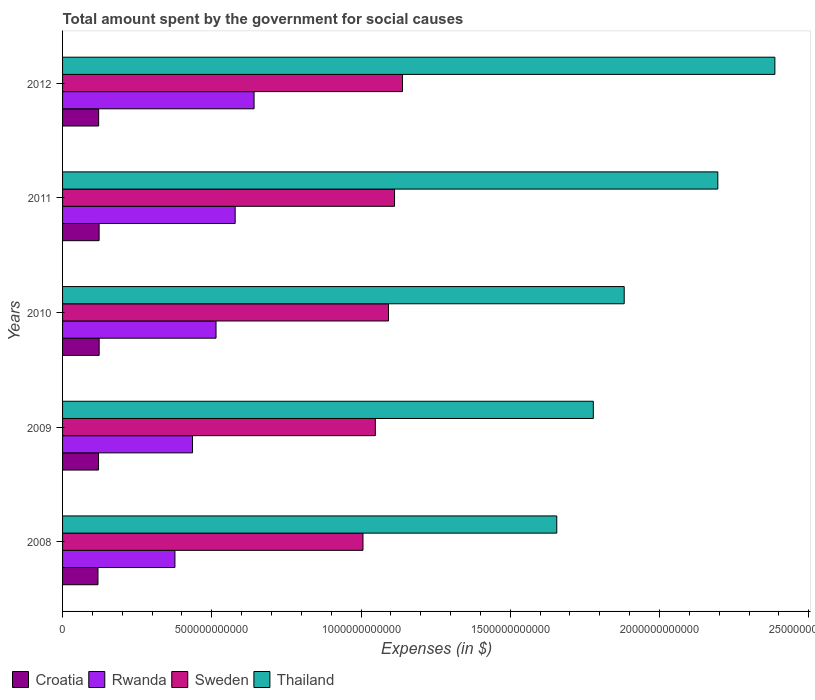Are the number of bars per tick equal to the number of legend labels?
Provide a succinct answer. Yes. How many bars are there on the 2nd tick from the top?
Your answer should be very brief. 4. In how many cases, is the number of bars for a given year not equal to the number of legend labels?
Offer a very short reply. 0. What is the amount spent for social causes by the government in Thailand in 2011?
Your response must be concise. 2.20e+12. Across all years, what is the maximum amount spent for social causes by the government in Thailand?
Keep it short and to the point. 2.39e+12. Across all years, what is the minimum amount spent for social causes by the government in Thailand?
Provide a short and direct response. 1.66e+12. What is the total amount spent for social causes by the government in Rwanda in the graph?
Offer a terse response. 2.55e+12. What is the difference between the amount spent for social causes by the government in Thailand in 2008 and that in 2010?
Provide a short and direct response. -2.26e+11. What is the difference between the amount spent for social causes by the government in Rwanda in 2010 and the amount spent for social causes by the government in Sweden in 2011?
Ensure brevity in your answer.  -5.98e+11. What is the average amount spent for social causes by the government in Rwanda per year?
Your answer should be compact. 5.09e+11. In the year 2012, what is the difference between the amount spent for social causes by the government in Thailand and amount spent for social causes by the government in Sweden?
Your response must be concise. 1.25e+12. What is the ratio of the amount spent for social causes by the government in Croatia in 2009 to that in 2011?
Offer a very short reply. 0.98. What is the difference between the highest and the second highest amount spent for social causes by the government in Thailand?
Make the answer very short. 1.91e+11. What is the difference between the highest and the lowest amount spent for social causes by the government in Sweden?
Offer a terse response. 1.32e+11. In how many years, is the amount spent for social causes by the government in Rwanda greater than the average amount spent for social causes by the government in Rwanda taken over all years?
Offer a very short reply. 3. Is the sum of the amount spent for social causes by the government in Rwanda in 2010 and 2012 greater than the maximum amount spent for social causes by the government in Sweden across all years?
Make the answer very short. Yes. Is it the case that in every year, the sum of the amount spent for social causes by the government in Rwanda and amount spent for social causes by the government in Croatia is greater than the sum of amount spent for social causes by the government in Thailand and amount spent for social causes by the government in Sweden?
Provide a succinct answer. No. What does the 4th bar from the top in 2011 represents?
Your answer should be very brief. Croatia. What does the 3rd bar from the bottom in 2008 represents?
Offer a terse response. Sweden. Is it the case that in every year, the sum of the amount spent for social causes by the government in Croatia and amount spent for social causes by the government in Thailand is greater than the amount spent for social causes by the government in Sweden?
Your answer should be compact. Yes. How many bars are there?
Your answer should be compact. 20. Are all the bars in the graph horizontal?
Make the answer very short. Yes. How many years are there in the graph?
Your answer should be very brief. 5. What is the difference between two consecutive major ticks on the X-axis?
Your answer should be very brief. 5.00e+11. Does the graph contain grids?
Offer a terse response. No. How many legend labels are there?
Provide a short and direct response. 4. What is the title of the graph?
Your answer should be very brief. Total amount spent by the government for social causes. What is the label or title of the X-axis?
Offer a terse response. Expenses (in $). What is the label or title of the Y-axis?
Your answer should be compact. Years. What is the Expenses (in $) in Croatia in 2008?
Provide a short and direct response. 1.19e+11. What is the Expenses (in $) in Rwanda in 2008?
Keep it short and to the point. 3.77e+11. What is the Expenses (in $) in Sweden in 2008?
Your response must be concise. 1.01e+12. What is the Expenses (in $) in Thailand in 2008?
Keep it short and to the point. 1.66e+12. What is the Expenses (in $) of Croatia in 2009?
Provide a short and direct response. 1.21e+11. What is the Expenses (in $) in Rwanda in 2009?
Offer a very short reply. 4.35e+11. What is the Expenses (in $) of Sweden in 2009?
Make the answer very short. 1.05e+12. What is the Expenses (in $) in Thailand in 2009?
Give a very brief answer. 1.78e+12. What is the Expenses (in $) in Croatia in 2010?
Keep it short and to the point. 1.23e+11. What is the Expenses (in $) in Rwanda in 2010?
Your answer should be compact. 5.14e+11. What is the Expenses (in $) in Sweden in 2010?
Provide a short and direct response. 1.09e+12. What is the Expenses (in $) of Thailand in 2010?
Ensure brevity in your answer.  1.88e+12. What is the Expenses (in $) of Croatia in 2011?
Your answer should be compact. 1.22e+11. What is the Expenses (in $) of Rwanda in 2011?
Your answer should be very brief. 5.78e+11. What is the Expenses (in $) of Sweden in 2011?
Your response must be concise. 1.11e+12. What is the Expenses (in $) of Thailand in 2011?
Make the answer very short. 2.20e+12. What is the Expenses (in $) of Croatia in 2012?
Provide a short and direct response. 1.21e+11. What is the Expenses (in $) of Rwanda in 2012?
Ensure brevity in your answer.  6.42e+11. What is the Expenses (in $) of Sweden in 2012?
Provide a succinct answer. 1.14e+12. What is the Expenses (in $) in Thailand in 2012?
Provide a short and direct response. 2.39e+12. Across all years, what is the maximum Expenses (in $) in Croatia?
Offer a terse response. 1.23e+11. Across all years, what is the maximum Expenses (in $) of Rwanda?
Provide a succinct answer. 6.42e+11. Across all years, what is the maximum Expenses (in $) in Sweden?
Give a very brief answer. 1.14e+12. Across all years, what is the maximum Expenses (in $) of Thailand?
Offer a very short reply. 2.39e+12. Across all years, what is the minimum Expenses (in $) of Croatia?
Your answer should be compact. 1.19e+11. Across all years, what is the minimum Expenses (in $) in Rwanda?
Provide a short and direct response. 3.77e+11. Across all years, what is the minimum Expenses (in $) of Sweden?
Your response must be concise. 1.01e+12. Across all years, what is the minimum Expenses (in $) of Thailand?
Your answer should be compact. 1.66e+12. What is the total Expenses (in $) of Croatia in the graph?
Offer a very short reply. 6.05e+11. What is the total Expenses (in $) in Rwanda in the graph?
Your answer should be very brief. 2.55e+12. What is the total Expenses (in $) in Sweden in the graph?
Give a very brief answer. 5.40e+12. What is the total Expenses (in $) of Thailand in the graph?
Your response must be concise. 9.90e+12. What is the difference between the Expenses (in $) in Croatia in 2008 and that in 2009?
Ensure brevity in your answer.  -1.87e+09. What is the difference between the Expenses (in $) in Rwanda in 2008 and that in 2009?
Offer a terse response. -5.89e+1. What is the difference between the Expenses (in $) of Sweden in 2008 and that in 2009?
Offer a very short reply. -4.14e+1. What is the difference between the Expenses (in $) in Thailand in 2008 and that in 2009?
Your answer should be very brief. -1.22e+11. What is the difference between the Expenses (in $) of Croatia in 2008 and that in 2010?
Your answer should be very brief. -3.90e+09. What is the difference between the Expenses (in $) in Rwanda in 2008 and that in 2010?
Offer a very short reply. -1.38e+11. What is the difference between the Expenses (in $) of Sweden in 2008 and that in 2010?
Your answer should be compact. -8.54e+1. What is the difference between the Expenses (in $) of Thailand in 2008 and that in 2010?
Provide a short and direct response. -2.26e+11. What is the difference between the Expenses (in $) of Croatia in 2008 and that in 2011?
Offer a terse response. -3.74e+09. What is the difference between the Expenses (in $) of Rwanda in 2008 and that in 2011?
Give a very brief answer. -2.02e+11. What is the difference between the Expenses (in $) of Sweden in 2008 and that in 2011?
Provide a short and direct response. -1.06e+11. What is the difference between the Expenses (in $) of Thailand in 2008 and that in 2011?
Offer a very short reply. -5.40e+11. What is the difference between the Expenses (in $) of Croatia in 2008 and that in 2012?
Your response must be concise. -2.24e+09. What is the difference between the Expenses (in $) of Rwanda in 2008 and that in 2012?
Your answer should be very brief. -2.65e+11. What is the difference between the Expenses (in $) of Sweden in 2008 and that in 2012?
Give a very brief answer. -1.32e+11. What is the difference between the Expenses (in $) of Thailand in 2008 and that in 2012?
Offer a terse response. -7.31e+11. What is the difference between the Expenses (in $) of Croatia in 2009 and that in 2010?
Your answer should be compact. -2.03e+09. What is the difference between the Expenses (in $) in Rwanda in 2009 and that in 2010?
Your response must be concise. -7.88e+1. What is the difference between the Expenses (in $) in Sweden in 2009 and that in 2010?
Ensure brevity in your answer.  -4.40e+1. What is the difference between the Expenses (in $) in Thailand in 2009 and that in 2010?
Provide a succinct answer. -1.04e+11. What is the difference between the Expenses (in $) in Croatia in 2009 and that in 2011?
Keep it short and to the point. -1.87e+09. What is the difference between the Expenses (in $) of Rwanda in 2009 and that in 2011?
Provide a short and direct response. -1.43e+11. What is the difference between the Expenses (in $) in Sweden in 2009 and that in 2011?
Ensure brevity in your answer.  -6.43e+1. What is the difference between the Expenses (in $) in Thailand in 2009 and that in 2011?
Offer a very short reply. -4.17e+11. What is the difference between the Expenses (in $) of Croatia in 2009 and that in 2012?
Provide a succinct answer. -3.77e+08. What is the difference between the Expenses (in $) of Rwanda in 2009 and that in 2012?
Offer a very short reply. -2.06e+11. What is the difference between the Expenses (in $) of Sweden in 2009 and that in 2012?
Keep it short and to the point. -9.10e+1. What is the difference between the Expenses (in $) of Thailand in 2009 and that in 2012?
Provide a short and direct response. -6.08e+11. What is the difference between the Expenses (in $) in Croatia in 2010 and that in 2011?
Offer a very short reply. 1.56e+08. What is the difference between the Expenses (in $) in Rwanda in 2010 and that in 2011?
Offer a terse response. -6.41e+1. What is the difference between the Expenses (in $) in Sweden in 2010 and that in 2011?
Your response must be concise. -2.03e+1. What is the difference between the Expenses (in $) in Thailand in 2010 and that in 2011?
Make the answer very short. -3.14e+11. What is the difference between the Expenses (in $) of Croatia in 2010 and that in 2012?
Ensure brevity in your answer.  1.65e+09. What is the difference between the Expenses (in $) of Rwanda in 2010 and that in 2012?
Your response must be concise. -1.27e+11. What is the difference between the Expenses (in $) of Sweden in 2010 and that in 2012?
Keep it short and to the point. -4.70e+1. What is the difference between the Expenses (in $) of Thailand in 2010 and that in 2012?
Your answer should be very brief. -5.05e+11. What is the difference between the Expenses (in $) in Croatia in 2011 and that in 2012?
Provide a succinct answer. 1.50e+09. What is the difference between the Expenses (in $) in Rwanda in 2011 and that in 2012?
Your answer should be very brief. -6.33e+1. What is the difference between the Expenses (in $) of Sweden in 2011 and that in 2012?
Your answer should be very brief. -2.66e+1. What is the difference between the Expenses (in $) in Thailand in 2011 and that in 2012?
Provide a short and direct response. -1.91e+11. What is the difference between the Expenses (in $) of Croatia in 2008 and the Expenses (in $) of Rwanda in 2009?
Keep it short and to the point. -3.17e+11. What is the difference between the Expenses (in $) of Croatia in 2008 and the Expenses (in $) of Sweden in 2009?
Offer a very short reply. -9.29e+11. What is the difference between the Expenses (in $) of Croatia in 2008 and the Expenses (in $) of Thailand in 2009?
Your response must be concise. -1.66e+12. What is the difference between the Expenses (in $) of Rwanda in 2008 and the Expenses (in $) of Sweden in 2009?
Ensure brevity in your answer.  -6.72e+11. What is the difference between the Expenses (in $) of Rwanda in 2008 and the Expenses (in $) of Thailand in 2009?
Ensure brevity in your answer.  -1.40e+12. What is the difference between the Expenses (in $) in Sweden in 2008 and the Expenses (in $) in Thailand in 2009?
Keep it short and to the point. -7.72e+11. What is the difference between the Expenses (in $) of Croatia in 2008 and the Expenses (in $) of Rwanda in 2010?
Provide a succinct answer. -3.96e+11. What is the difference between the Expenses (in $) of Croatia in 2008 and the Expenses (in $) of Sweden in 2010?
Keep it short and to the point. -9.73e+11. What is the difference between the Expenses (in $) of Croatia in 2008 and the Expenses (in $) of Thailand in 2010?
Keep it short and to the point. -1.76e+12. What is the difference between the Expenses (in $) of Rwanda in 2008 and the Expenses (in $) of Sweden in 2010?
Your response must be concise. -7.16e+11. What is the difference between the Expenses (in $) of Rwanda in 2008 and the Expenses (in $) of Thailand in 2010?
Provide a succinct answer. -1.51e+12. What is the difference between the Expenses (in $) of Sweden in 2008 and the Expenses (in $) of Thailand in 2010?
Provide a succinct answer. -8.75e+11. What is the difference between the Expenses (in $) of Croatia in 2008 and the Expenses (in $) of Rwanda in 2011?
Keep it short and to the point. -4.60e+11. What is the difference between the Expenses (in $) of Croatia in 2008 and the Expenses (in $) of Sweden in 2011?
Give a very brief answer. -9.94e+11. What is the difference between the Expenses (in $) of Croatia in 2008 and the Expenses (in $) of Thailand in 2011?
Your answer should be compact. -2.08e+12. What is the difference between the Expenses (in $) in Rwanda in 2008 and the Expenses (in $) in Sweden in 2011?
Keep it short and to the point. -7.36e+11. What is the difference between the Expenses (in $) of Rwanda in 2008 and the Expenses (in $) of Thailand in 2011?
Offer a very short reply. -1.82e+12. What is the difference between the Expenses (in $) of Sweden in 2008 and the Expenses (in $) of Thailand in 2011?
Make the answer very short. -1.19e+12. What is the difference between the Expenses (in $) of Croatia in 2008 and the Expenses (in $) of Rwanda in 2012?
Provide a short and direct response. -5.23e+11. What is the difference between the Expenses (in $) in Croatia in 2008 and the Expenses (in $) in Sweden in 2012?
Ensure brevity in your answer.  -1.02e+12. What is the difference between the Expenses (in $) in Croatia in 2008 and the Expenses (in $) in Thailand in 2012?
Ensure brevity in your answer.  -2.27e+12. What is the difference between the Expenses (in $) of Rwanda in 2008 and the Expenses (in $) of Sweden in 2012?
Offer a terse response. -7.62e+11. What is the difference between the Expenses (in $) in Rwanda in 2008 and the Expenses (in $) in Thailand in 2012?
Your answer should be compact. -2.01e+12. What is the difference between the Expenses (in $) of Sweden in 2008 and the Expenses (in $) of Thailand in 2012?
Keep it short and to the point. -1.38e+12. What is the difference between the Expenses (in $) in Croatia in 2009 and the Expenses (in $) in Rwanda in 2010?
Keep it short and to the point. -3.94e+11. What is the difference between the Expenses (in $) of Croatia in 2009 and the Expenses (in $) of Sweden in 2010?
Provide a succinct answer. -9.71e+11. What is the difference between the Expenses (in $) of Croatia in 2009 and the Expenses (in $) of Thailand in 2010?
Offer a very short reply. -1.76e+12. What is the difference between the Expenses (in $) of Rwanda in 2009 and the Expenses (in $) of Sweden in 2010?
Your response must be concise. -6.57e+11. What is the difference between the Expenses (in $) of Rwanda in 2009 and the Expenses (in $) of Thailand in 2010?
Your answer should be very brief. -1.45e+12. What is the difference between the Expenses (in $) of Sweden in 2009 and the Expenses (in $) of Thailand in 2010?
Keep it short and to the point. -8.34e+11. What is the difference between the Expenses (in $) of Croatia in 2009 and the Expenses (in $) of Rwanda in 2011?
Make the answer very short. -4.58e+11. What is the difference between the Expenses (in $) in Croatia in 2009 and the Expenses (in $) in Sweden in 2011?
Ensure brevity in your answer.  -9.92e+11. What is the difference between the Expenses (in $) in Croatia in 2009 and the Expenses (in $) in Thailand in 2011?
Give a very brief answer. -2.07e+12. What is the difference between the Expenses (in $) of Rwanda in 2009 and the Expenses (in $) of Sweden in 2011?
Provide a short and direct response. -6.77e+11. What is the difference between the Expenses (in $) in Rwanda in 2009 and the Expenses (in $) in Thailand in 2011?
Provide a short and direct response. -1.76e+12. What is the difference between the Expenses (in $) of Sweden in 2009 and the Expenses (in $) of Thailand in 2011?
Your answer should be very brief. -1.15e+12. What is the difference between the Expenses (in $) in Croatia in 2009 and the Expenses (in $) in Rwanda in 2012?
Provide a short and direct response. -5.21e+11. What is the difference between the Expenses (in $) in Croatia in 2009 and the Expenses (in $) in Sweden in 2012?
Ensure brevity in your answer.  -1.02e+12. What is the difference between the Expenses (in $) of Croatia in 2009 and the Expenses (in $) of Thailand in 2012?
Keep it short and to the point. -2.27e+12. What is the difference between the Expenses (in $) of Rwanda in 2009 and the Expenses (in $) of Sweden in 2012?
Your answer should be compact. -7.04e+11. What is the difference between the Expenses (in $) of Rwanda in 2009 and the Expenses (in $) of Thailand in 2012?
Offer a terse response. -1.95e+12. What is the difference between the Expenses (in $) of Sweden in 2009 and the Expenses (in $) of Thailand in 2012?
Your answer should be very brief. -1.34e+12. What is the difference between the Expenses (in $) of Croatia in 2010 and the Expenses (in $) of Rwanda in 2011?
Provide a short and direct response. -4.56e+11. What is the difference between the Expenses (in $) in Croatia in 2010 and the Expenses (in $) in Sweden in 2011?
Ensure brevity in your answer.  -9.90e+11. What is the difference between the Expenses (in $) of Croatia in 2010 and the Expenses (in $) of Thailand in 2011?
Your response must be concise. -2.07e+12. What is the difference between the Expenses (in $) of Rwanda in 2010 and the Expenses (in $) of Sweden in 2011?
Ensure brevity in your answer.  -5.98e+11. What is the difference between the Expenses (in $) of Rwanda in 2010 and the Expenses (in $) of Thailand in 2011?
Your answer should be very brief. -1.68e+12. What is the difference between the Expenses (in $) in Sweden in 2010 and the Expenses (in $) in Thailand in 2011?
Provide a short and direct response. -1.10e+12. What is the difference between the Expenses (in $) in Croatia in 2010 and the Expenses (in $) in Rwanda in 2012?
Provide a succinct answer. -5.19e+11. What is the difference between the Expenses (in $) of Croatia in 2010 and the Expenses (in $) of Sweden in 2012?
Your answer should be very brief. -1.02e+12. What is the difference between the Expenses (in $) of Croatia in 2010 and the Expenses (in $) of Thailand in 2012?
Offer a terse response. -2.26e+12. What is the difference between the Expenses (in $) in Rwanda in 2010 and the Expenses (in $) in Sweden in 2012?
Keep it short and to the point. -6.25e+11. What is the difference between the Expenses (in $) of Rwanda in 2010 and the Expenses (in $) of Thailand in 2012?
Keep it short and to the point. -1.87e+12. What is the difference between the Expenses (in $) in Sweden in 2010 and the Expenses (in $) in Thailand in 2012?
Your answer should be compact. -1.29e+12. What is the difference between the Expenses (in $) in Croatia in 2011 and the Expenses (in $) in Rwanda in 2012?
Make the answer very short. -5.19e+11. What is the difference between the Expenses (in $) in Croatia in 2011 and the Expenses (in $) in Sweden in 2012?
Provide a succinct answer. -1.02e+12. What is the difference between the Expenses (in $) of Croatia in 2011 and the Expenses (in $) of Thailand in 2012?
Offer a very short reply. -2.26e+12. What is the difference between the Expenses (in $) of Rwanda in 2011 and the Expenses (in $) of Sweden in 2012?
Offer a very short reply. -5.61e+11. What is the difference between the Expenses (in $) in Rwanda in 2011 and the Expenses (in $) in Thailand in 2012?
Make the answer very short. -1.81e+12. What is the difference between the Expenses (in $) of Sweden in 2011 and the Expenses (in $) of Thailand in 2012?
Give a very brief answer. -1.27e+12. What is the average Expenses (in $) of Croatia per year?
Your answer should be compact. 1.21e+11. What is the average Expenses (in $) of Rwanda per year?
Your answer should be compact. 5.09e+11. What is the average Expenses (in $) of Sweden per year?
Give a very brief answer. 1.08e+12. What is the average Expenses (in $) in Thailand per year?
Provide a short and direct response. 1.98e+12. In the year 2008, what is the difference between the Expenses (in $) of Croatia and Expenses (in $) of Rwanda?
Offer a very short reply. -2.58e+11. In the year 2008, what is the difference between the Expenses (in $) in Croatia and Expenses (in $) in Sweden?
Ensure brevity in your answer.  -8.88e+11. In the year 2008, what is the difference between the Expenses (in $) of Croatia and Expenses (in $) of Thailand?
Give a very brief answer. -1.54e+12. In the year 2008, what is the difference between the Expenses (in $) in Rwanda and Expenses (in $) in Sweden?
Give a very brief answer. -6.30e+11. In the year 2008, what is the difference between the Expenses (in $) of Rwanda and Expenses (in $) of Thailand?
Provide a succinct answer. -1.28e+12. In the year 2008, what is the difference between the Expenses (in $) in Sweden and Expenses (in $) in Thailand?
Ensure brevity in your answer.  -6.49e+11. In the year 2009, what is the difference between the Expenses (in $) of Croatia and Expenses (in $) of Rwanda?
Offer a terse response. -3.15e+11. In the year 2009, what is the difference between the Expenses (in $) of Croatia and Expenses (in $) of Sweden?
Offer a very short reply. -9.27e+11. In the year 2009, what is the difference between the Expenses (in $) of Croatia and Expenses (in $) of Thailand?
Keep it short and to the point. -1.66e+12. In the year 2009, what is the difference between the Expenses (in $) of Rwanda and Expenses (in $) of Sweden?
Keep it short and to the point. -6.13e+11. In the year 2009, what is the difference between the Expenses (in $) in Rwanda and Expenses (in $) in Thailand?
Ensure brevity in your answer.  -1.34e+12. In the year 2009, what is the difference between the Expenses (in $) in Sweden and Expenses (in $) in Thailand?
Ensure brevity in your answer.  -7.30e+11. In the year 2010, what is the difference between the Expenses (in $) in Croatia and Expenses (in $) in Rwanda?
Keep it short and to the point. -3.92e+11. In the year 2010, what is the difference between the Expenses (in $) of Croatia and Expenses (in $) of Sweden?
Your answer should be very brief. -9.69e+11. In the year 2010, what is the difference between the Expenses (in $) in Croatia and Expenses (in $) in Thailand?
Your answer should be very brief. -1.76e+12. In the year 2010, what is the difference between the Expenses (in $) of Rwanda and Expenses (in $) of Sweden?
Make the answer very short. -5.78e+11. In the year 2010, what is the difference between the Expenses (in $) of Rwanda and Expenses (in $) of Thailand?
Offer a terse response. -1.37e+12. In the year 2010, what is the difference between the Expenses (in $) in Sweden and Expenses (in $) in Thailand?
Your response must be concise. -7.90e+11. In the year 2011, what is the difference between the Expenses (in $) in Croatia and Expenses (in $) in Rwanda?
Provide a short and direct response. -4.56e+11. In the year 2011, what is the difference between the Expenses (in $) of Croatia and Expenses (in $) of Sweden?
Ensure brevity in your answer.  -9.90e+11. In the year 2011, what is the difference between the Expenses (in $) in Croatia and Expenses (in $) in Thailand?
Ensure brevity in your answer.  -2.07e+12. In the year 2011, what is the difference between the Expenses (in $) of Rwanda and Expenses (in $) of Sweden?
Keep it short and to the point. -5.34e+11. In the year 2011, what is the difference between the Expenses (in $) in Rwanda and Expenses (in $) in Thailand?
Your answer should be very brief. -1.62e+12. In the year 2011, what is the difference between the Expenses (in $) in Sweden and Expenses (in $) in Thailand?
Provide a short and direct response. -1.08e+12. In the year 2012, what is the difference between the Expenses (in $) of Croatia and Expenses (in $) of Rwanda?
Ensure brevity in your answer.  -5.21e+11. In the year 2012, what is the difference between the Expenses (in $) of Croatia and Expenses (in $) of Sweden?
Your answer should be compact. -1.02e+12. In the year 2012, what is the difference between the Expenses (in $) in Croatia and Expenses (in $) in Thailand?
Your response must be concise. -2.27e+12. In the year 2012, what is the difference between the Expenses (in $) in Rwanda and Expenses (in $) in Sweden?
Your answer should be very brief. -4.97e+11. In the year 2012, what is the difference between the Expenses (in $) of Rwanda and Expenses (in $) of Thailand?
Provide a succinct answer. -1.75e+12. In the year 2012, what is the difference between the Expenses (in $) of Sweden and Expenses (in $) of Thailand?
Your answer should be compact. -1.25e+12. What is the ratio of the Expenses (in $) in Croatia in 2008 to that in 2009?
Provide a short and direct response. 0.98. What is the ratio of the Expenses (in $) of Rwanda in 2008 to that in 2009?
Provide a short and direct response. 0.86. What is the ratio of the Expenses (in $) in Sweden in 2008 to that in 2009?
Your answer should be very brief. 0.96. What is the ratio of the Expenses (in $) in Thailand in 2008 to that in 2009?
Your answer should be very brief. 0.93. What is the ratio of the Expenses (in $) of Croatia in 2008 to that in 2010?
Your response must be concise. 0.97. What is the ratio of the Expenses (in $) in Rwanda in 2008 to that in 2010?
Give a very brief answer. 0.73. What is the ratio of the Expenses (in $) of Sweden in 2008 to that in 2010?
Offer a very short reply. 0.92. What is the ratio of the Expenses (in $) of Thailand in 2008 to that in 2010?
Your response must be concise. 0.88. What is the ratio of the Expenses (in $) in Croatia in 2008 to that in 2011?
Your answer should be very brief. 0.97. What is the ratio of the Expenses (in $) in Rwanda in 2008 to that in 2011?
Give a very brief answer. 0.65. What is the ratio of the Expenses (in $) in Sweden in 2008 to that in 2011?
Ensure brevity in your answer.  0.9. What is the ratio of the Expenses (in $) of Thailand in 2008 to that in 2011?
Offer a terse response. 0.75. What is the ratio of the Expenses (in $) in Croatia in 2008 to that in 2012?
Keep it short and to the point. 0.98. What is the ratio of the Expenses (in $) of Rwanda in 2008 to that in 2012?
Offer a very short reply. 0.59. What is the ratio of the Expenses (in $) of Sweden in 2008 to that in 2012?
Provide a short and direct response. 0.88. What is the ratio of the Expenses (in $) in Thailand in 2008 to that in 2012?
Offer a terse response. 0.69. What is the ratio of the Expenses (in $) in Croatia in 2009 to that in 2010?
Your answer should be compact. 0.98. What is the ratio of the Expenses (in $) of Rwanda in 2009 to that in 2010?
Keep it short and to the point. 0.85. What is the ratio of the Expenses (in $) of Sweden in 2009 to that in 2010?
Give a very brief answer. 0.96. What is the ratio of the Expenses (in $) of Thailand in 2009 to that in 2010?
Offer a terse response. 0.94. What is the ratio of the Expenses (in $) in Croatia in 2009 to that in 2011?
Offer a very short reply. 0.98. What is the ratio of the Expenses (in $) in Rwanda in 2009 to that in 2011?
Give a very brief answer. 0.75. What is the ratio of the Expenses (in $) of Sweden in 2009 to that in 2011?
Give a very brief answer. 0.94. What is the ratio of the Expenses (in $) of Thailand in 2009 to that in 2011?
Keep it short and to the point. 0.81. What is the ratio of the Expenses (in $) in Croatia in 2009 to that in 2012?
Provide a succinct answer. 1. What is the ratio of the Expenses (in $) of Rwanda in 2009 to that in 2012?
Your answer should be compact. 0.68. What is the ratio of the Expenses (in $) in Sweden in 2009 to that in 2012?
Ensure brevity in your answer.  0.92. What is the ratio of the Expenses (in $) in Thailand in 2009 to that in 2012?
Provide a succinct answer. 0.75. What is the ratio of the Expenses (in $) in Rwanda in 2010 to that in 2011?
Ensure brevity in your answer.  0.89. What is the ratio of the Expenses (in $) of Sweden in 2010 to that in 2011?
Make the answer very short. 0.98. What is the ratio of the Expenses (in $) in Croatia in 2010 to that in 2012?
Your answer should be compact. 1.01. What is the ratio of the Expenses (in $) in Rwanda in 2010 to that in 2012?
Keep it short and to the point. 0.8. What is the ratio of the Expenses (in $) of Sweden in 2010 to that in 2012?
Keep it short and to the point. 0.96. What is the ratio of the Expenses (in $) of Thailand in 2010 to that in 2012?
Provide a succinct answer. 0.79. What is the ratio of the Expenses (in $) in Croatia in 2011 to that in 2012?
Provide a short and direct response. 1.01. What is the ratio of the Expenses (in $) in Rwanda in 2011 to that in 2012?
Your answer should be compact. 0.9. What is the ratio of the Expenses (in $) in Sweden in 2011 to that in 2012?
Give a very brief answer. 0.98. What is the ratio of the Expenses (in $) in Thailand in 2011 to that in 2012?
Ensure brevity in your answer.  0.92. What is the difference between the highest and the second highest Expenses (in $) in Croatia?
Your response must be concise. 1.56e+08. What is the difference between the highest and the second highest Expenses (in $) of Rwanda?
Make the answer very short. 6.33e+1. What is the difference between the highest and the second highest Expenses (in $) in Sweden?
Offer a terse response. 2.66e+1. What is the difference between the highest and the second highest Expenses (in $) in Thailand?
Your answer should be very brief. 1.91e+11. What is the difference between the highest and the lowest Expenses (in $) in Croatia?
Provide a short and direct response. 3.90e+09. What is the difference between the highest and the lowest Expenses (in $) in Rwanda?
Provide a succinct answer. 2.65e+11. What is the difference between the highest and the lowest Expenses (in $) of Sweden?
Offer a very short reply. 1.32e+11. What is the difference between the highest and the lowest Expenses (in $) in Thailand?
Offer a terse response. 7.31e+11. 